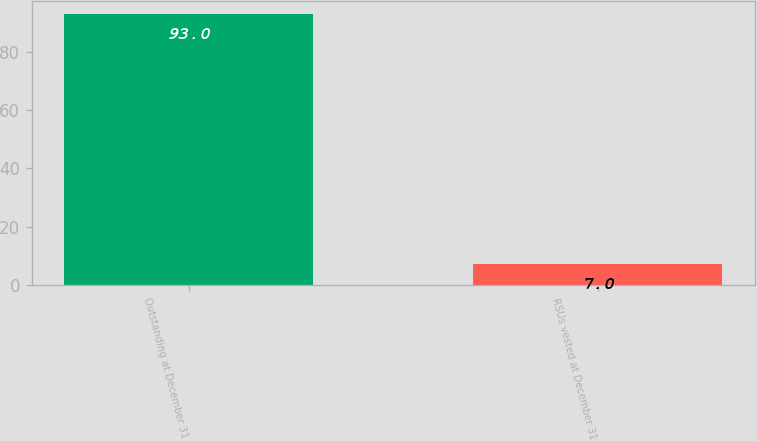Convert chart. <chart><loc_0><loc_0><loc_500><loc_500><bar_chart><fcel>Outstanding at December 31<fcel>RSUs vested at December 31<nl><fcel>93<fcel>7<nl></chart> 